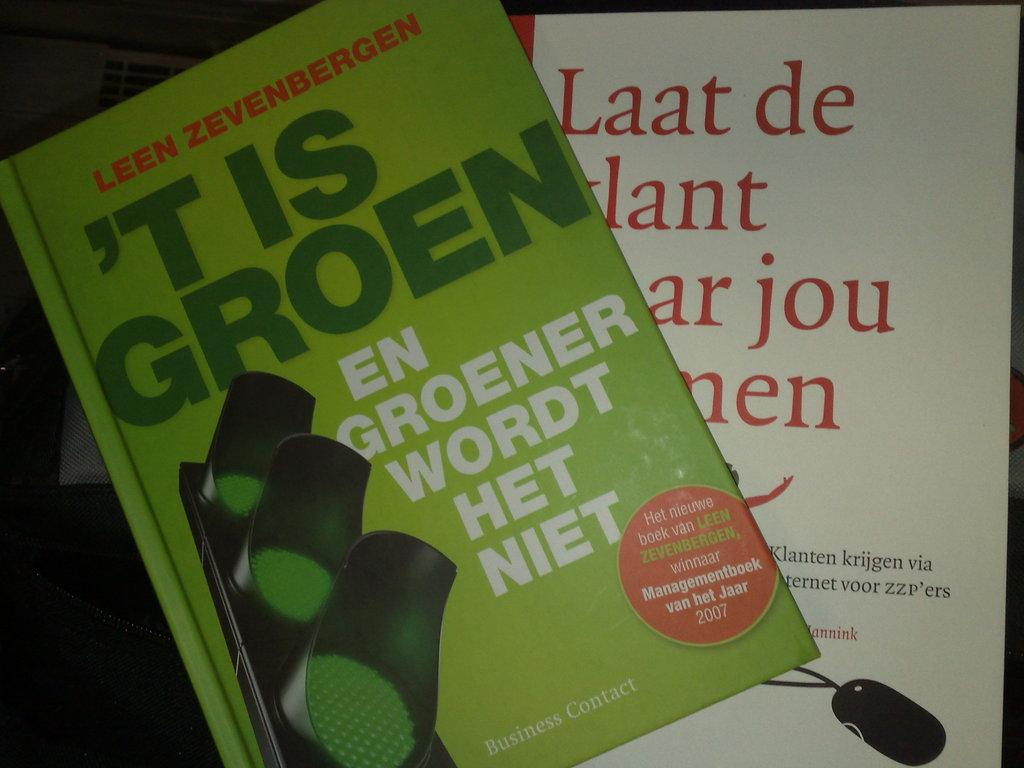<image>
Create a compact narrative representing the image presented. Two books titled 'T Is Groen and Laat de. 